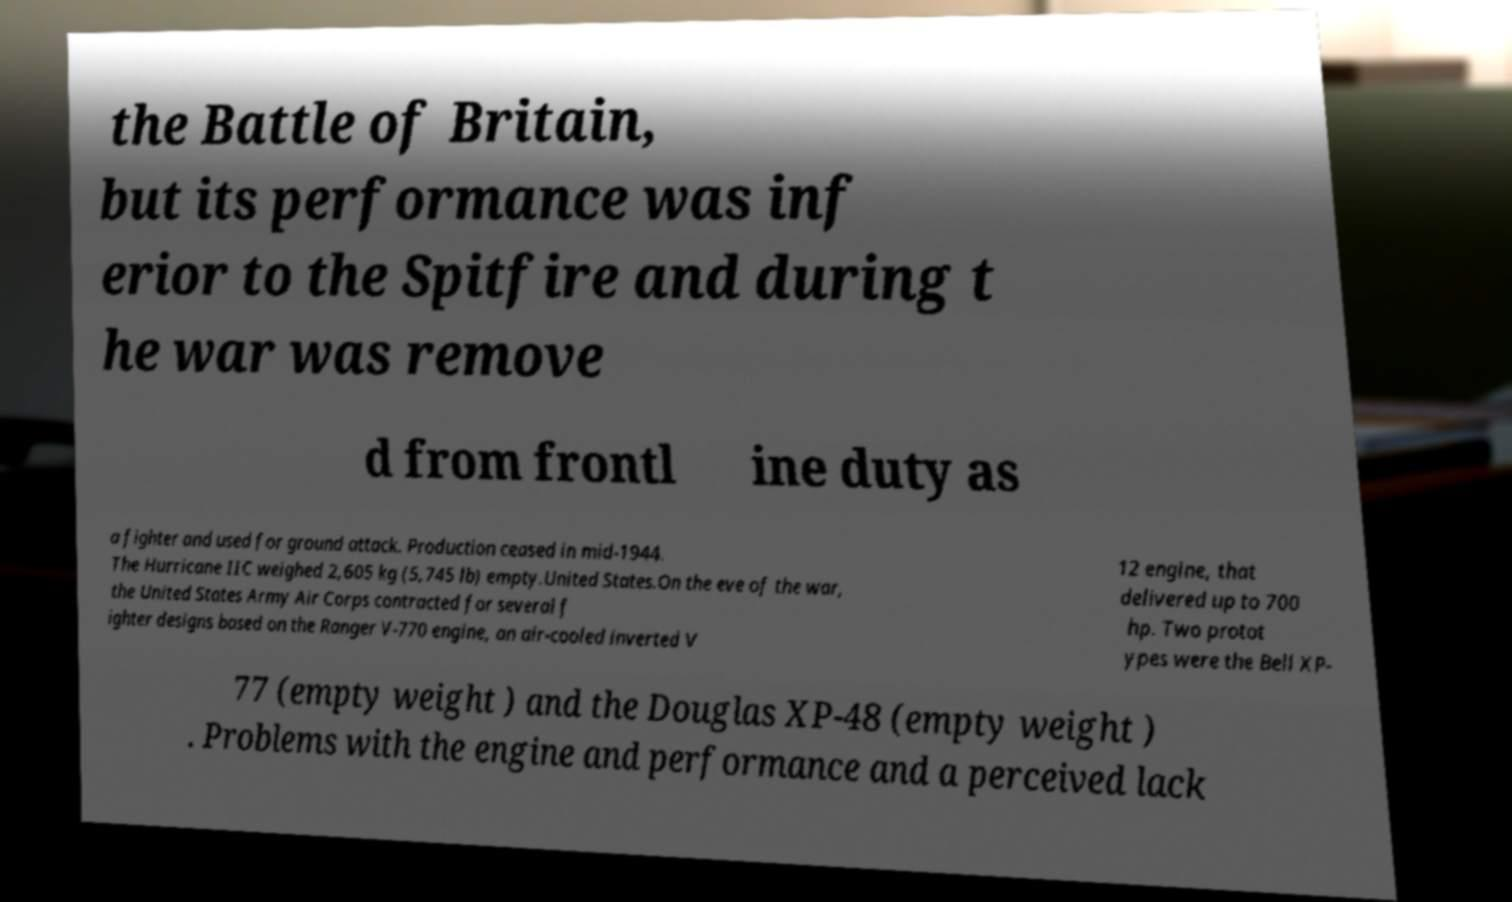There's text embedded in this image that I need extracted. Can you transcribe it verbatim? the Battle of Britain, but its performance was inf erior to the Spitfire and during t he war was remove d from frontl ine duty as a fighter and used for ground attack. Production ceased in mid-1944. The Hurricane IIC weighed 2,605 kg (5,745 lb) empty.United States.On the eve of the war, the United States Army Air Corps contracted for several f ighter designs based on the Ranger V-770 engine, an air-cooled inverted V 12 engine, that delivered up to 700 hp. Two protot ypes were the Bell XP- 77 (empty weight ) and the Douglas XP-48 (empty weight ) . Problems with the engine and performance and a perceived lack 